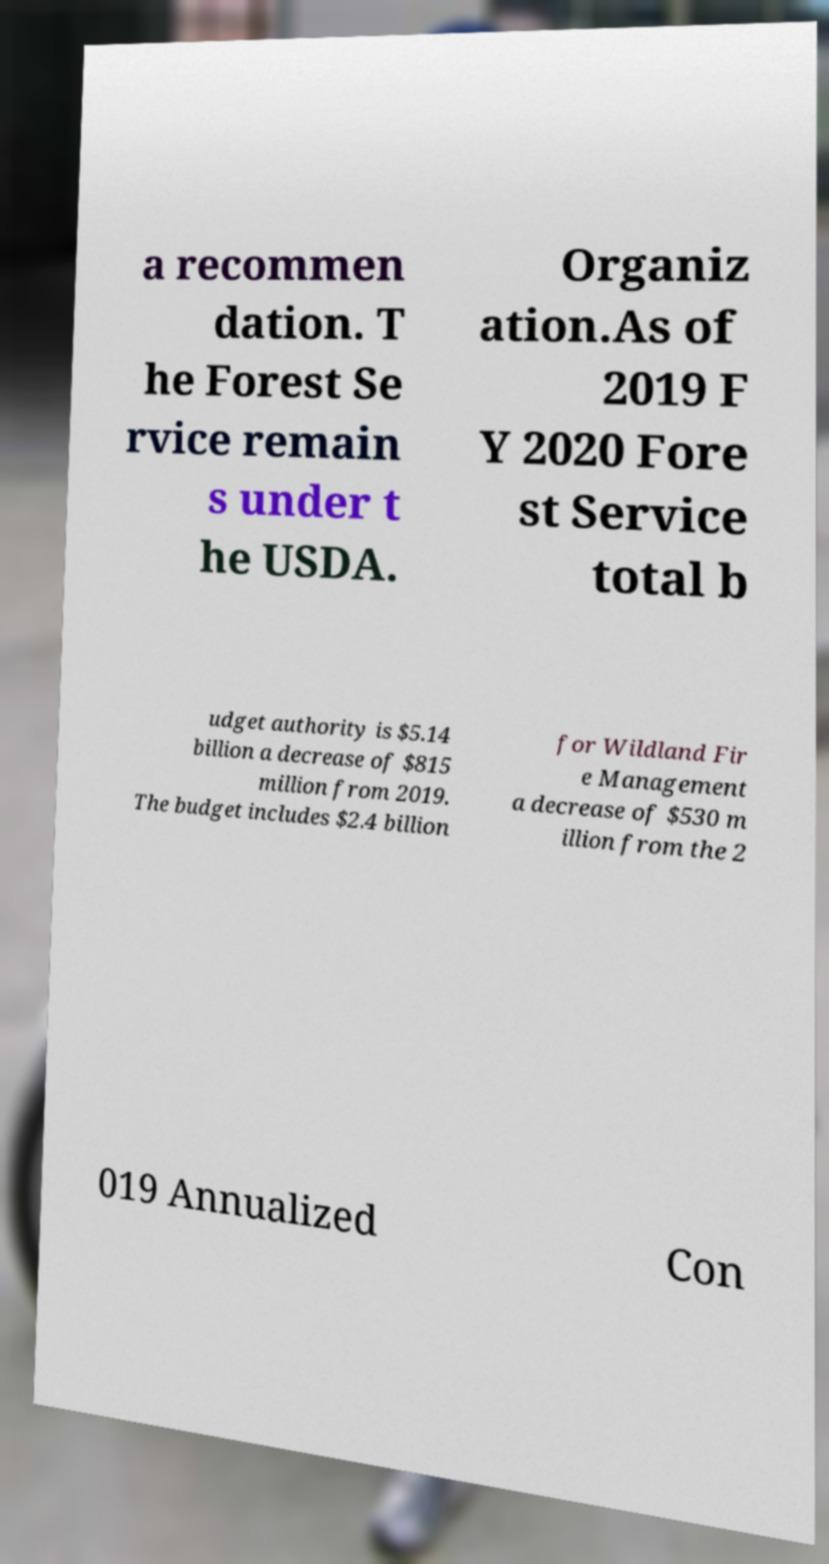Please read and relay the text visible in this image. What does it say? a recommen dation. T he Forest Se rvice remain s under t he USDA. Organiz ation.As of 2019 F Y 2020 Fore st Service total b udget authority is $5.14 billion a decrease of $815 million from 2019. The budget includes $2.4 billion for Wildland Fir e Management a decrease of $530 m illion from the 2 019 Annualized Con 